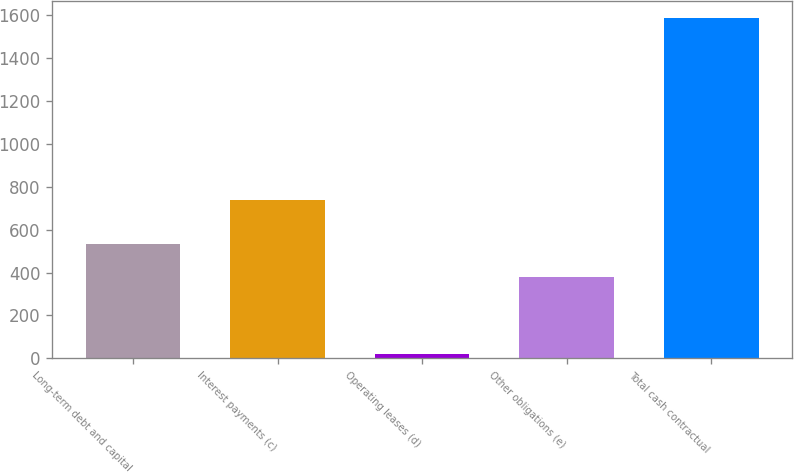Convert chart to OTSL. <chart><loc_0><loc_0><loc_500><loc_500><bar_chart><fcel>Long-term debt and capital<fcel>Interest payments (c)<fcel>Operating leases (d)<fcel>Other obligations (e)<fcel>Total cash contractual<nl><fcel>533.4<fcel>737<fcel>21<fcel>377<fcel>1585<nl></chart> 